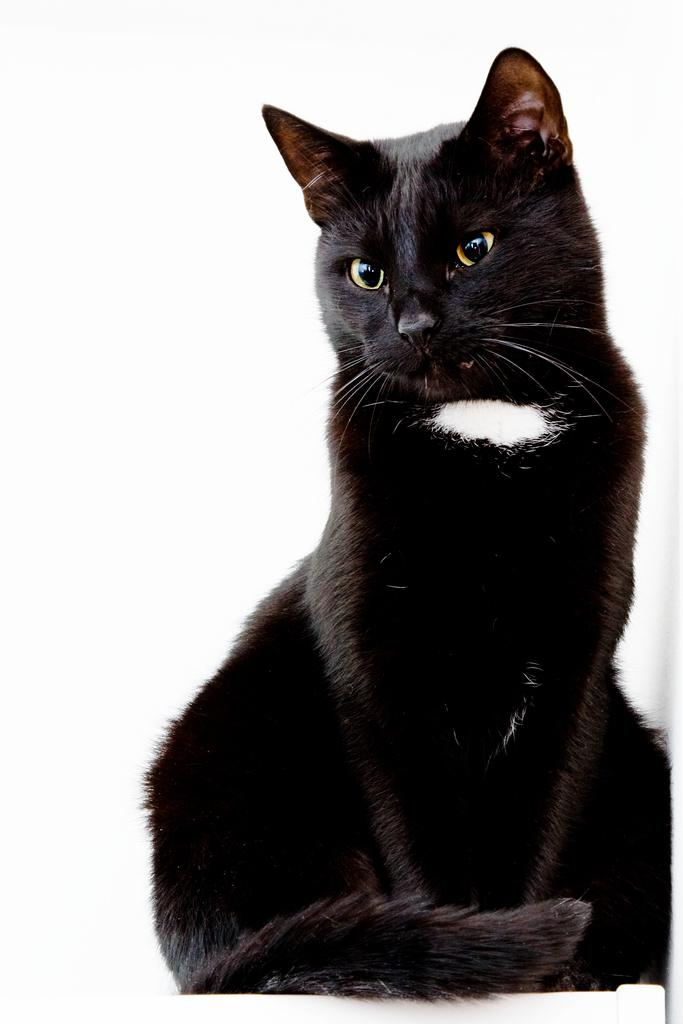What type of animal is in the image? There is a black cat in the image. What is the cat sitting on? The cat is on a white desk. What shape is the smoke coming from the cat's ears in the image? There is no smoke coming from the cat's ears in the image. 